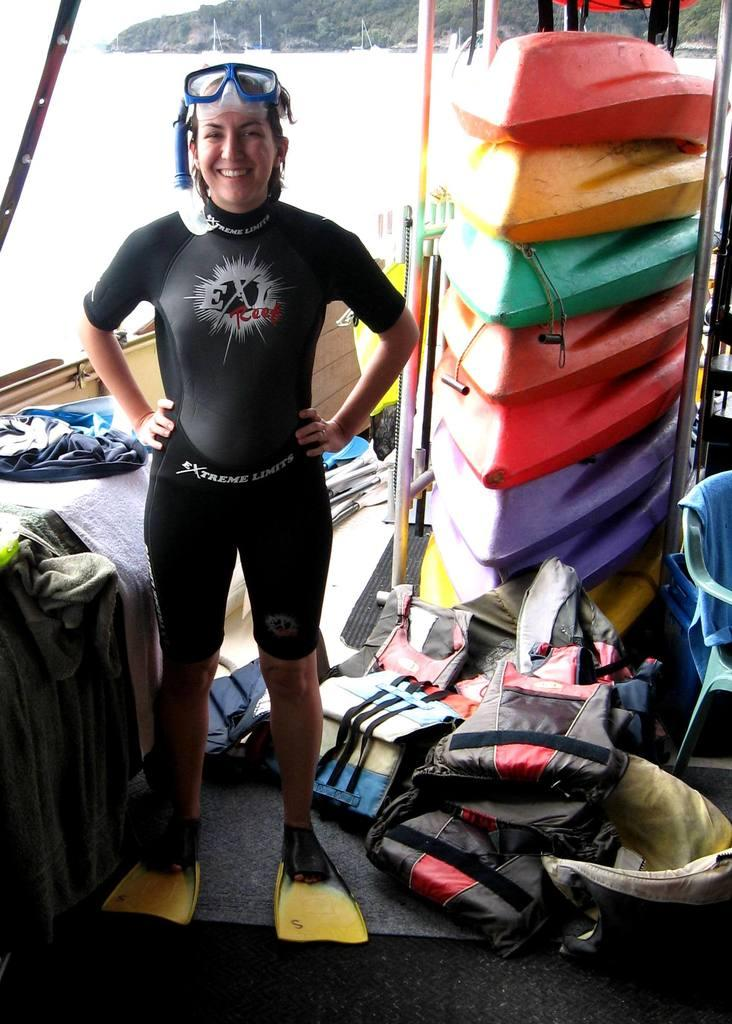Provide a one-sentence caption for the provided image. A person in a wet suit and flippers, standing in front of a stack of kayaks. 